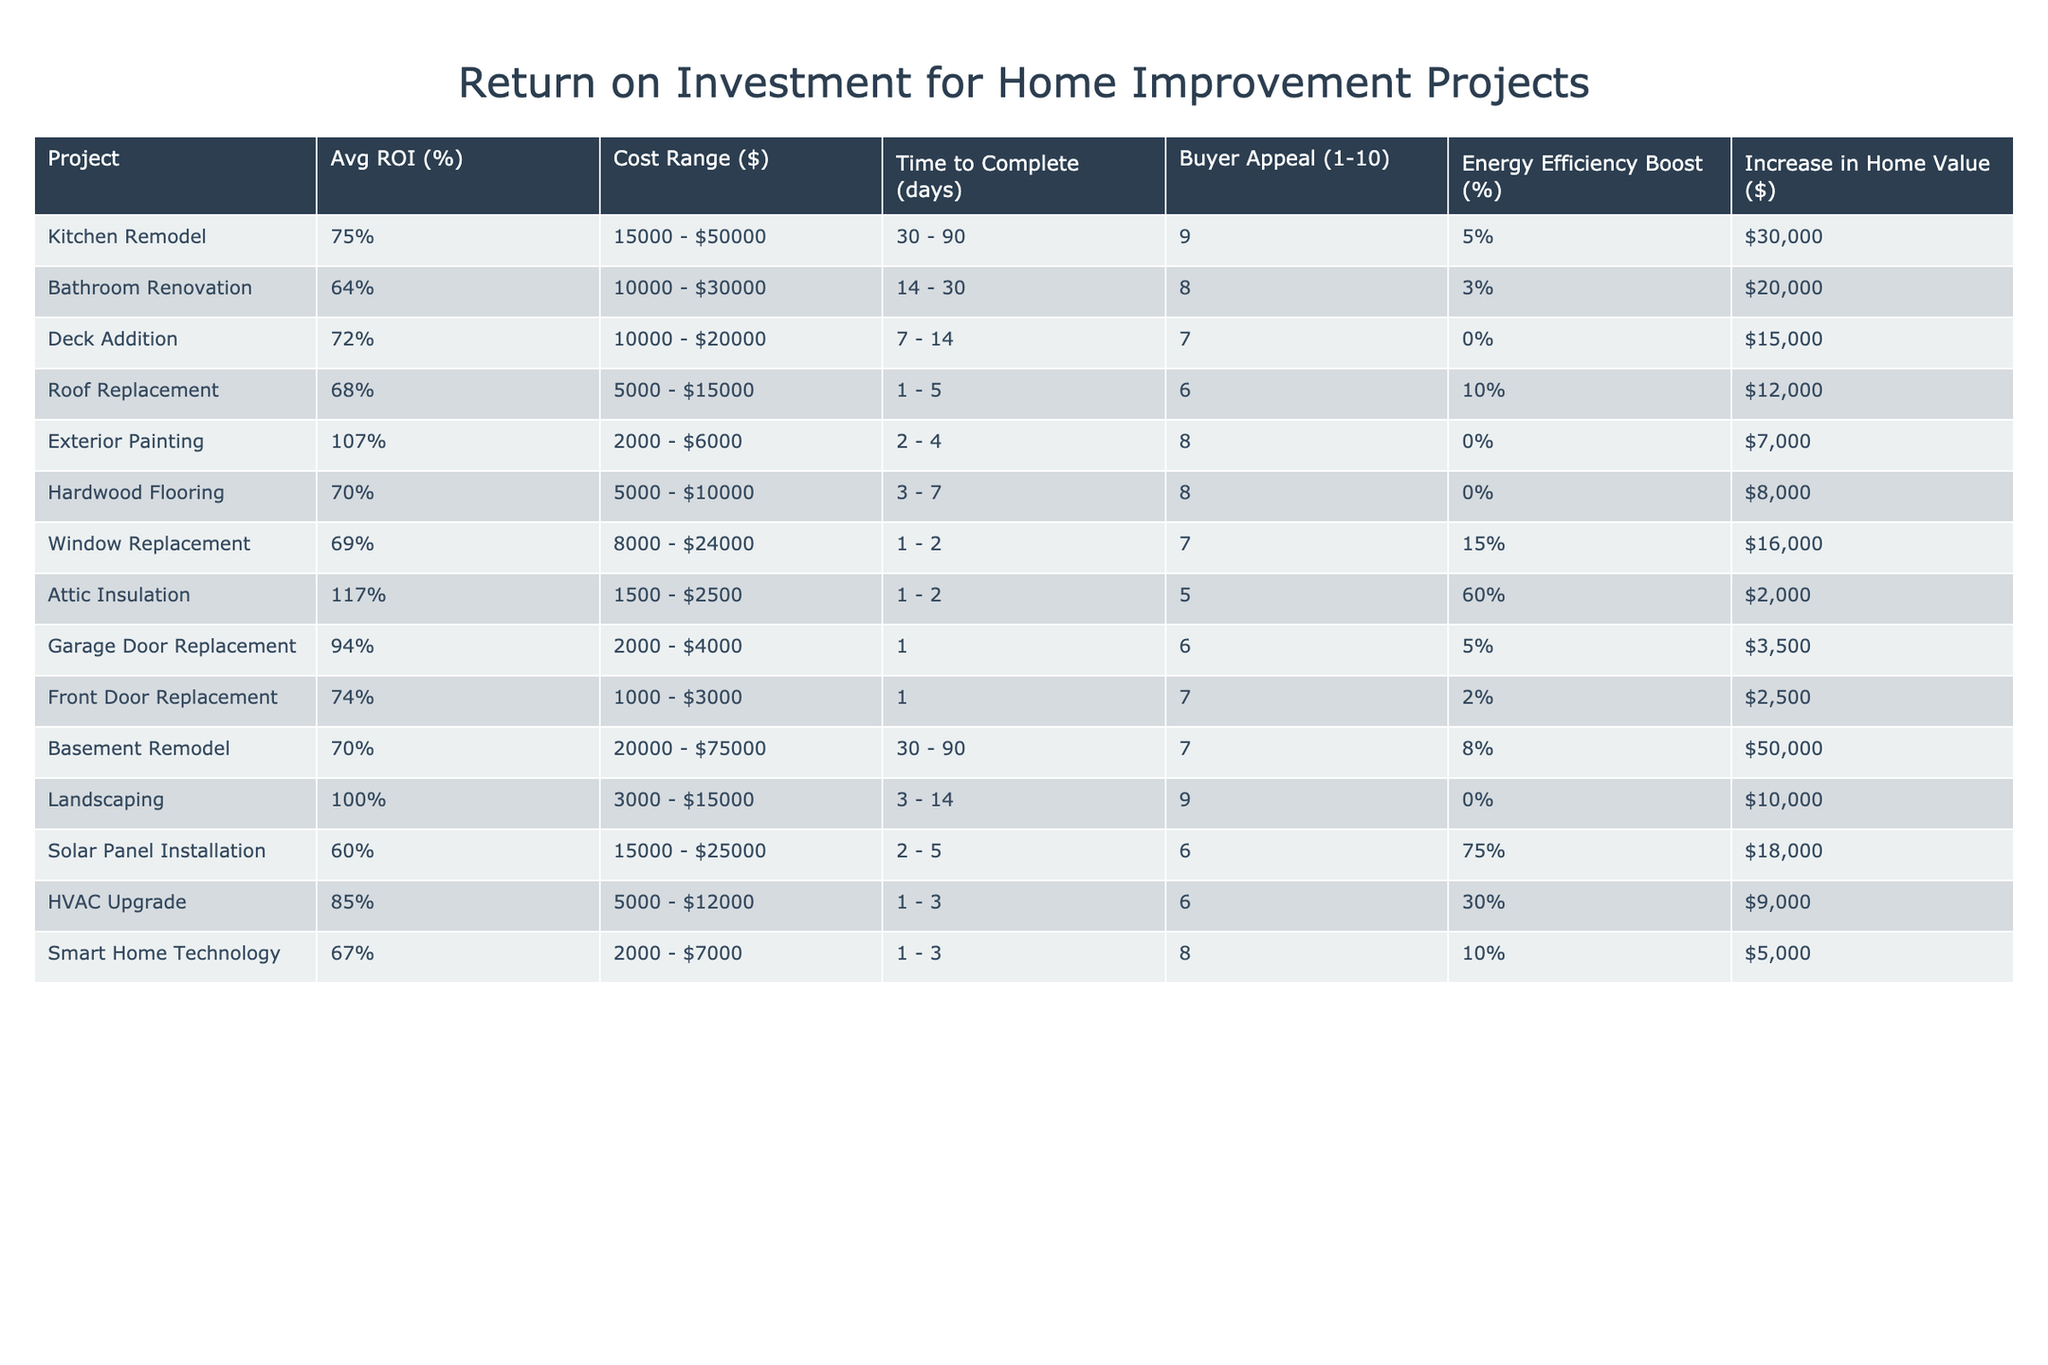What home improvement project has the highest average ROI? By examining the Avg ROI (%) column, we see that the Attic Insulation project has the highest value at 117%.
Answer: Attic Insulation What is the cost range for a bathroom renovation? The Cost Range ($) column for Bathroom Renovation shows the range as 10,000 - 30,000 dollars.
Answer: 10,000 - 30,000 dollars Which project takes the longest time to complete? Looking at the Time to Complete (days) column, both Kitchen Remodel and Basement Remodel list a time range of 30-90 days, indicating they take the longest.
Answer: Kitchen Remodel and Basement Remodel What is the increase in home value for a kitchen remodel? We can find the Increase in Home Value ($) for Kitchen Remodel in that column, which is 30,000 dollars.
Answer: 30,000 dollars Is landscaping more appealing to buyers than smart home technology? Comparing the Buyer Appeal (1-10) values, Landscaping has an appeal score of 9 while Smart Home Technology has a score of 8, which means Landscaping is indeed more appealing.
Answer: Yes What is the average ROI for projects with energy efficiency boosts over 50%? The relevant projects are Window Replacement (69%), Solar Panel Installation (60%), and Attic Insulation (117%). Their average ROI is calculated as (69 + 60 + 117) / 3 = 82%.
Answer: 82% What project has the lowest return on investment? By reviewing the Avg ROI (%) column, Solar Panel Installation shows the lowest ROI at 60%.
Answer: Solar Panel Installation How much does a roof replacement increase home value compared to an HVAC upgrade? The Increase in Home Value ($) for Roof Replacement is 12,000 dollars and for HVAC Upgrade is 9,000 dollars. The difference in values is 12,000 - 9,000 = 3,000 dollars.
Answer: 3,000 dollars Are there any projects that improve energy efficiency by more than 50%? Yes, projects like Window Replacement (15%), Solar Panel Installation (75%), and Attic Insulation (60%) exceed a 50% energy efficiency boost.
Answer: Yes What is the total cost range for all projects listed? To find the total cost range, we identify the minimum and maximum of the Cost Range ($) column. The lowest is 1,000 (Front Door Replacement) and the highest is 75,000 (Basement Remodel), giving a range of 1,000 - 75,000 dollars.
Answer: 1,000 - 75,000 dollars 